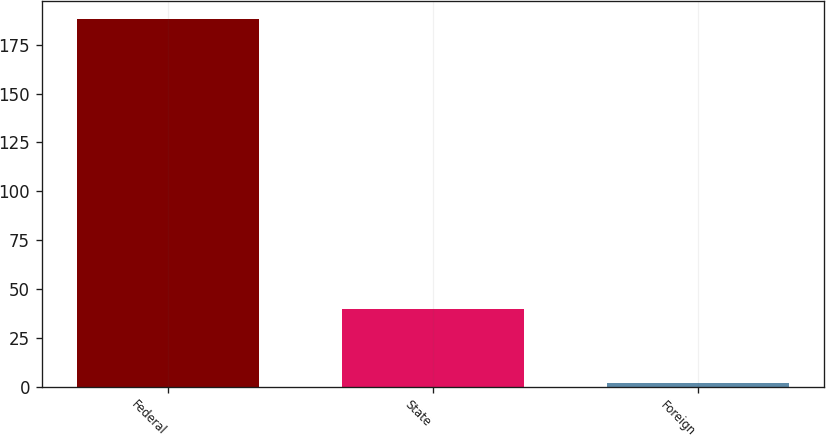<chart> <loc_0><loc_0><loc_500><loc_500><bar_chart><fcel>Federal<fcel>State<fcel>Foreign<nl><fcel>188<fcel>40<fcel>2<nl></chart> 